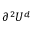<formula> <loc_0><loc_0><loc_500><loc_500>\partial ^ { 2 } U ^ { d }</formula> 